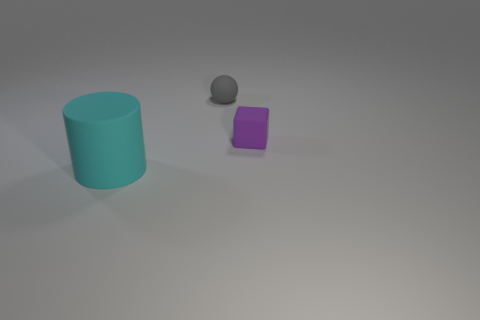Add 2 big cyan things. How many objects exist? 5 Subtract all blocks. How many objects are left? 2 Add 2 large cyan rubber cylinders. How many large cyan rubber cylinders are left? 3 Add 2 tiny gray spheres. How many tiny gray spheres exist? 3 Subtract 0 red spheres. How many objects are left? 3 Subtract all purple things. Subtract all big green spheres. How many objects are left? 2 